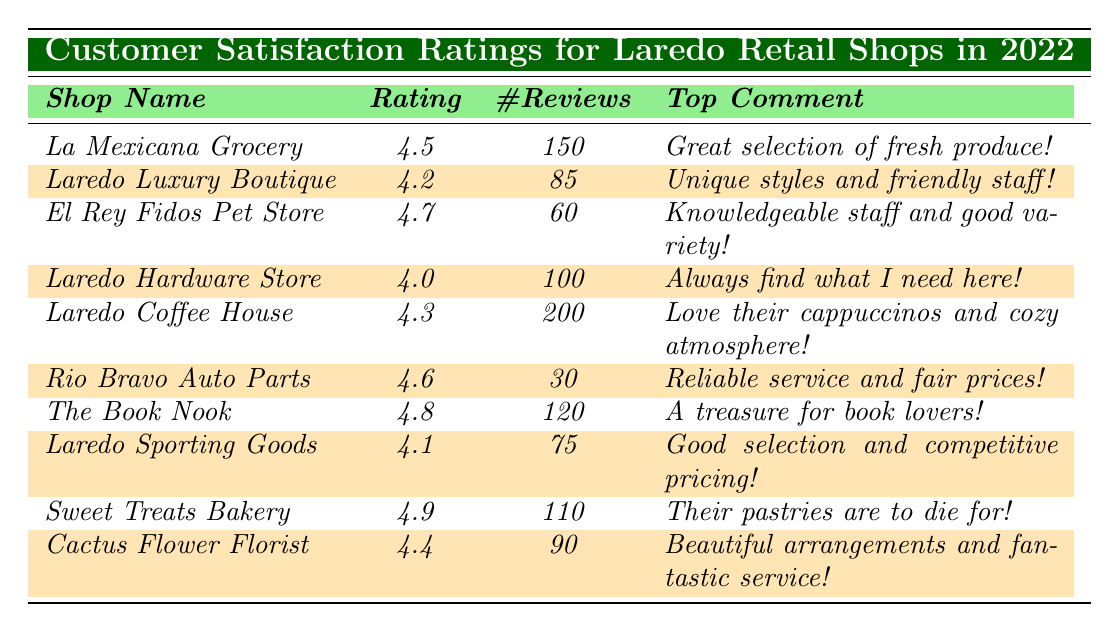What is the highest customer satisfaction rating among the shops? The ratings for each shop are as follows: La Mexicana Grocery (4.5), Laredo Luxury Boutique (4.2), El Rey Fidos Pet Store (4.7), Laredo Hardware Store (4.0), Laredo Coffee House (4.3), Rio Bravo Auto Parts (4.6), The Book Nook (4.8), Laredo Sporting Goods (4.1), Sweet Treats Bakery (4.9), Cactus Flower Florist (4.4). The highest rating is 4.9 for Sweet Treats Bakery.
Answer: 4.9 How many reviews did Laredo Coffee House receive? The table shows that Laredo Coffee House has a total of 200 reviews.
Answer: 200 Which shop has the lowest rating, and what is that rating? The ratings listed are as follows, and the lowest rating is for Laredo Hardware Store at 4.0.
Answer: Laredo Hardware Store; 4.0 What is the average rating of the shops listed in the table? To find the average, we first sum all the ratings: (4.5 + 4.2 + 4.7 + 4.0 + 4.3 + 4.6 + 4.8 + 4.1 + 4.9 + 4.4) = 45.7. There are 10 shops, so the average rating is 45.7 / 10 = 4.57.
Answer: 4.57 Is La Mexicana Grocery rated higher than Laredo Sporting Goods? La Mexicana Grocery has a rating of 4.5 while Laredo Sporting Goods has a rating of 4.1. Since 4.5 is greater than 4.1, La Mexicana Grocery is rated higher.
Answer: Yes What number of shops have a rating of 4.5 or higher? The shops with ratings of 4.5 or higher include La Mexicana Grocery (4.5), El Rey Fidos Pet Store (4.7), Laredo Coffee House (4.3), Rio Bravo Auto Parts (4.6), The Book Nook (4.8), Sweet Treats Bakery (4.9), and Cactus Flower Florist (4.4). There are a total of 7 shops with ratings of 4.5 or higher.
Answer: 7 Which shop has the most reviews, and how many reviews does it have? Laredo Coffee House has the highest number of reviews at 200, as indicated in the table.
Answer: Laredo Coffee House; 200 What is the difference in the number of reviews between Sweet Treats Bakery and El Rey Fidos Pet Store? Sweet Treats Bakery has 110 reviews, and El Rey Fidos Pet Store has 60 reviews. The difference is 110 - 60 = 50.
Answer: 50 Which shop's top comment contains the word "friendly"? The top comment for Laredo Luxury Boutique is "Unique styles and friendly staff!" Therefore, it contains the word "friendly."
Answer: Laredo Luxury Boutique Are there any shops with a rating less than 4.1? The ratings show that Laredo Hardware Store has a rating of 4.0, which is less than 4.1, confirming that there is at least one shop with a rating under 4.1.
Answer: Yes If we consider only shops with the highest ratings (4.8 and above), how many reviews do they collectively have? The shops with ratings of 4.8 and above are The Book Nook (120 reviews) and Sweet Treats Bakery (110 reviews). Adding these, we get 120 + 110 = 230 total reviews.
Answer: 230 